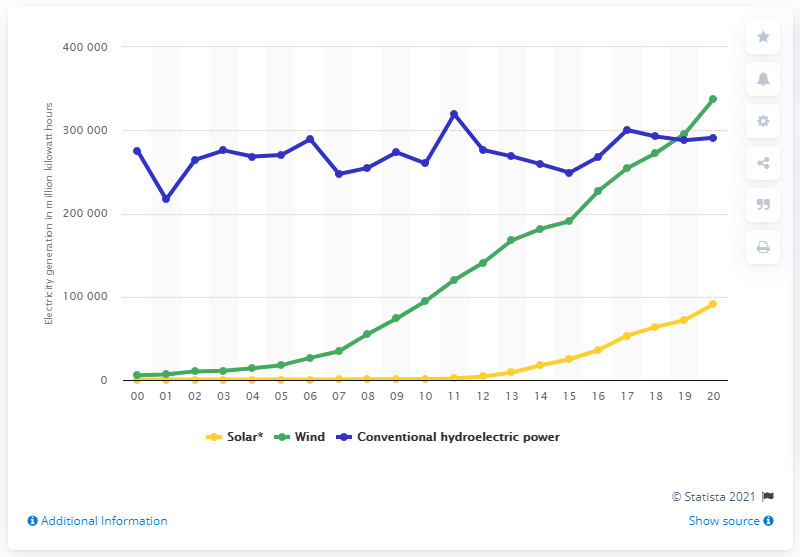Draw attention to some important aspects in this diagram. In 2020, the United States generated 908,911 megawatt-hours of electricity from solar sources. In 2020, the United States generated a total of 337,510 megawatt-hours of electricity from wind energy, which represents a significant increase from previous years. 